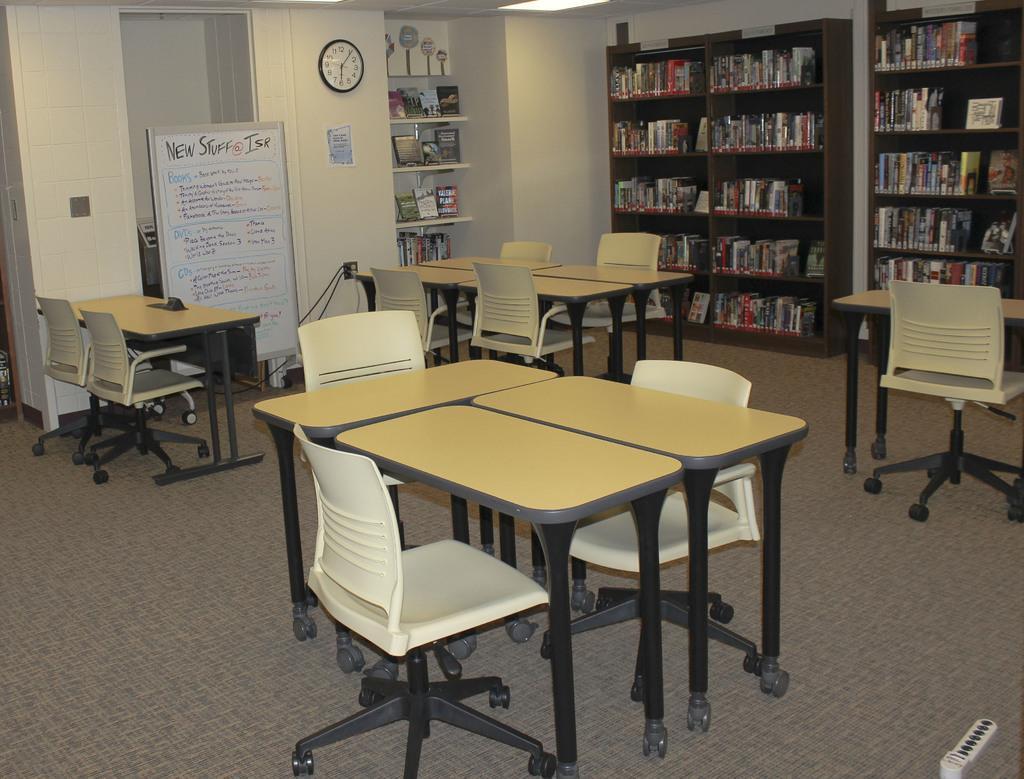Describe this image in one or two sentences. In this picture there is a table in the center of the image and there are chairs around it and there are other tables and chairs in the background area of the image and there is a board on the left side of the image, there are bookshelves in the background area of the image. 